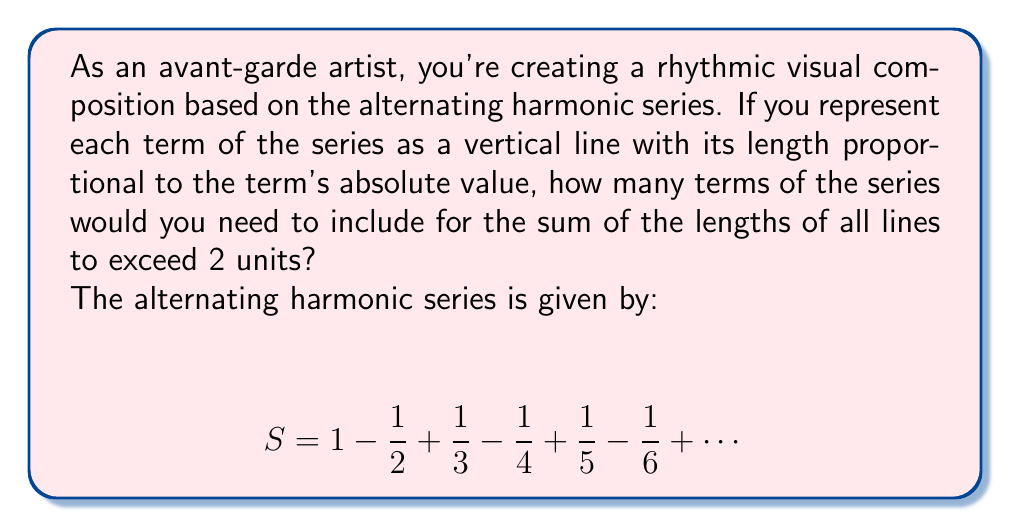Solve this math problem. Let's approach this step-by-step:

1) First, we need to consider the series of absolute values of the terms:

   $$ \sum_{n=1}^{\infty} \frac{1}{n} = 1 + \frac{1}{2} + \frac{1}{3} + \frac{1}{4} + \frac{1}{5} + \frac{1}{6} + \cdots $$

2) We need to find the smallest $k$ such that:

   $$ \sum_{n=1}^{k} \frac{1}{n} > 2 $$

3) Let's calculate the partial sums:
   
   $S_1 = 1 = 1$
   $S_2 = 1 + \frac{1}{2} = 1.5$
   $S_3 = 1 + \frac{1}{2} + \frac{1}{3} \approx 1.833$
   $S_4 = 1 + \frac{1}{2} + \frac{1}{3} + \frac{1}{4} \approx 2.083$

4) We see that $S_4 > 2$, but $S_3 < 2$.

5) Therefore, we need 4 terms of the alternating harmonic series for the sum of the absolute values to exceed 2.

This means in your visual composition, you would need to draw 4 vertical lines with lengths proportional to 1, 1/2, 1/3, and 1/4 respectively.
Answer: 4 terms 